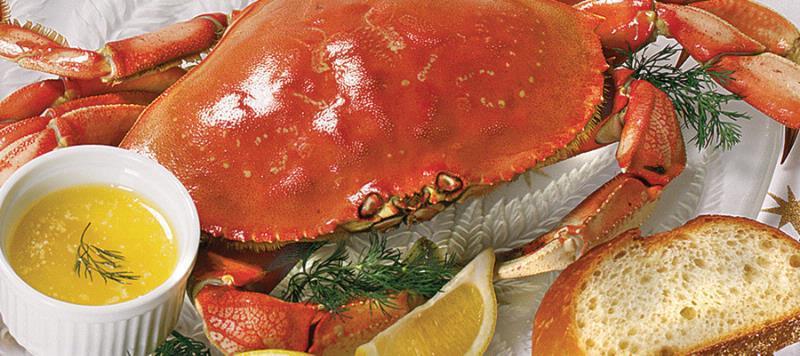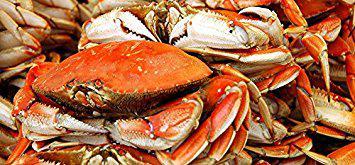The first image is the image on the left, the second image is the image on the right. Given the left and right images, does the statement "There are crab legs separated from the body." hold true? Answer yes or no. No. The first image is the image on the left, the second image is the image on the right. For the images shown, is this caption "A single whole crab is on a white plate with dipping sauce next to it." true? Answer yes or no. Yes. 